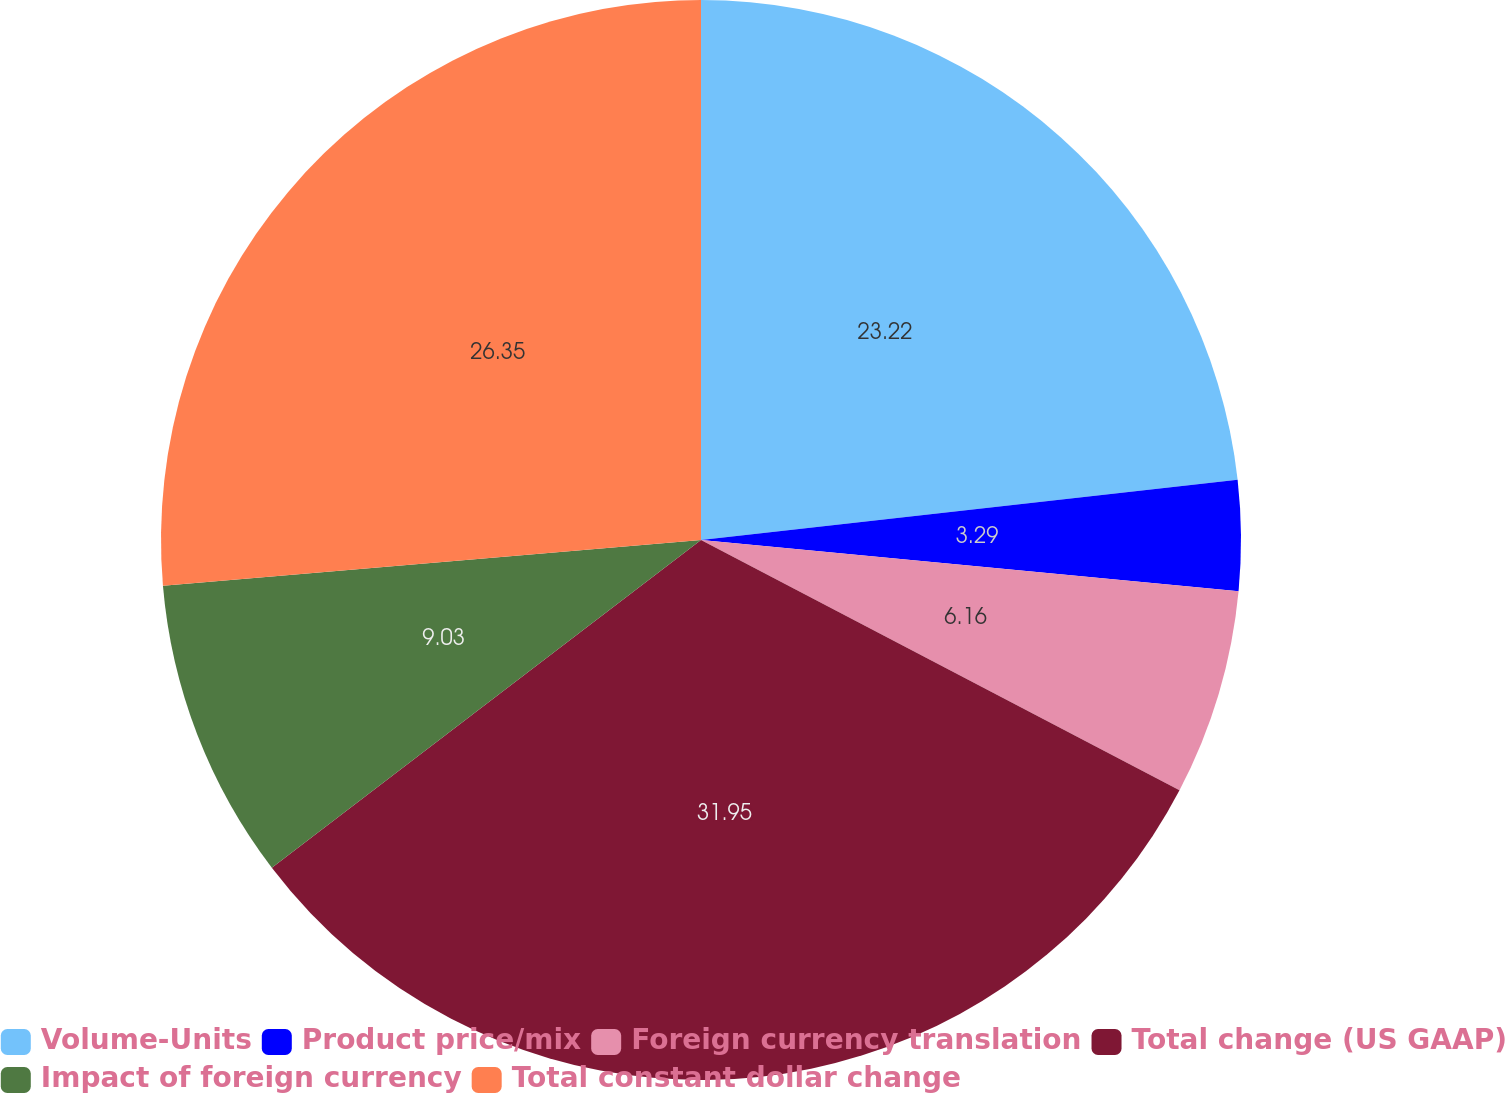Convert chart to OTSL. <chart><loc_0><loc_0><loc_500><loc_500><pie_chart><fcel>Volume-Units<fcel>Product price/mix<fcel>Foreign currency translation<fcel>Total change (US GAAP)<fcel>Impact of foreign currency<fcel>Total constant dollar change<nl><fcel>23.22%<fcel>3.29%<fcel>6.16%<fcel>31.95%<fcel>9.03%<fcel>26.35%<nl></chart> 